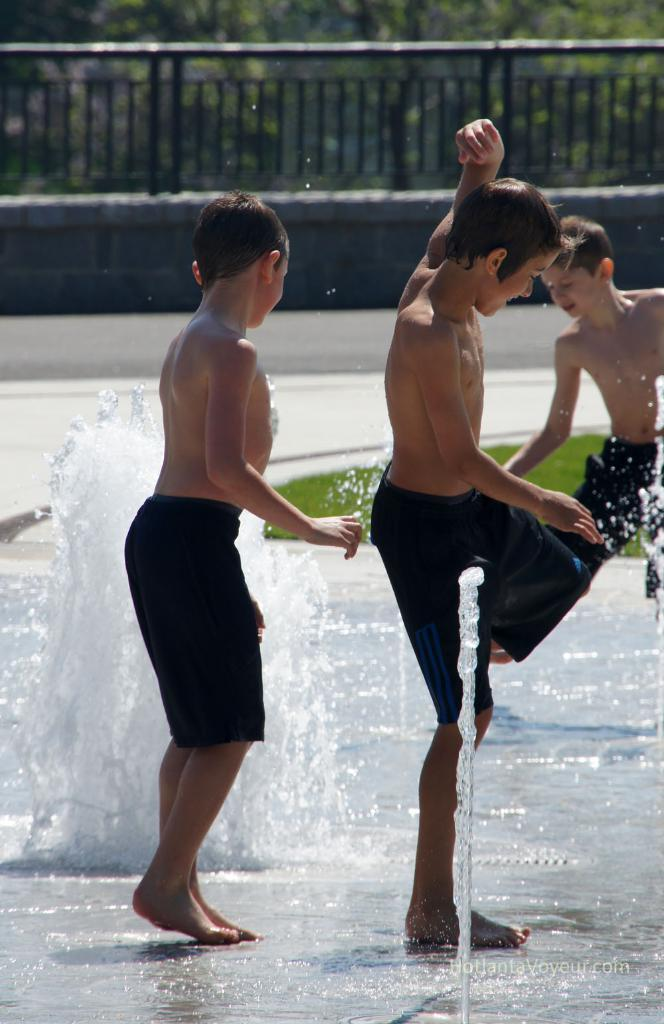What are the kids in the image doing? The kids are playing in the image. What are the kids playing with? The kids are playing with water. What can be seen in the background of the image? There is a black fence in the background of the image. What type of pancake is being served at the airport in the image? There is no airport or pancake present in the image; it features kids playing with water and a black fence in the background. 